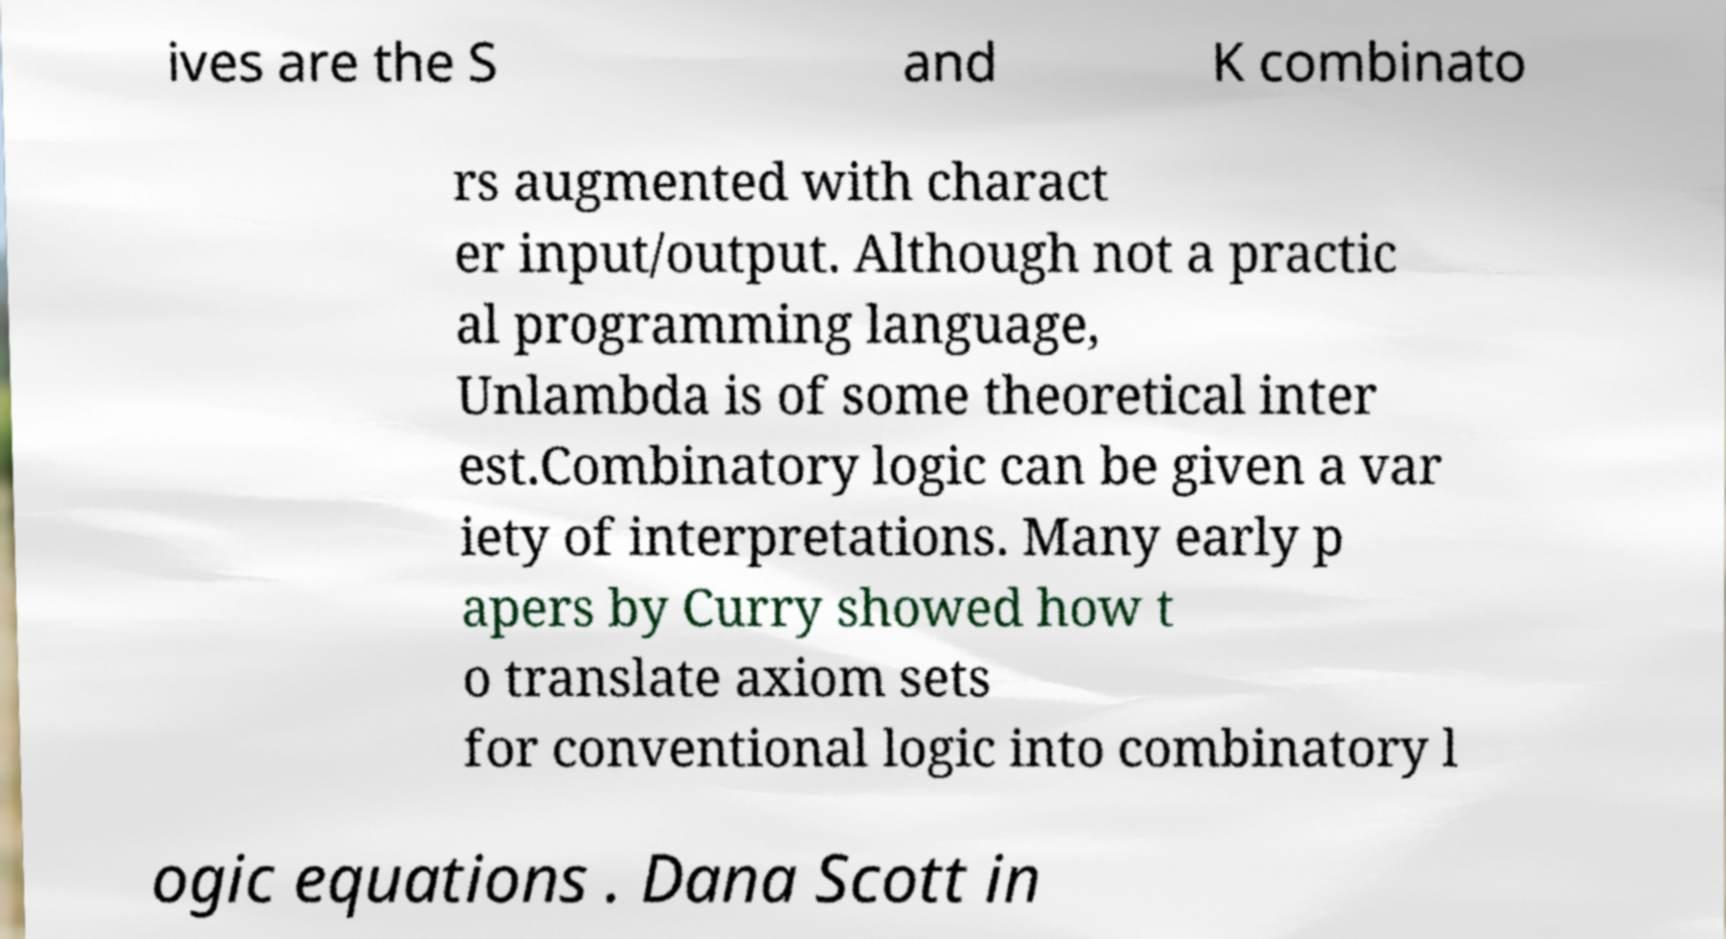What messages or text are displayed in this image? I need them in a readable, typed format. ives are the S and K combinato rs augmented with charact er input/output. Although not a practic al programming language, Unlambda is of some theoretical inter est.Combinatory logic can be given a var iety of interpretations. Many early p apers by Curry showed how t o translate axiom sets for conventional logic into combinatory l ogic equations . Dana Scott in 